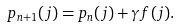<formula> <loc_0><loc_0><loc_500><loc_500>p _ { n + 1 } ( j ) = p _ { n } ( j ) + \gamma f ( j ) .</formula> 